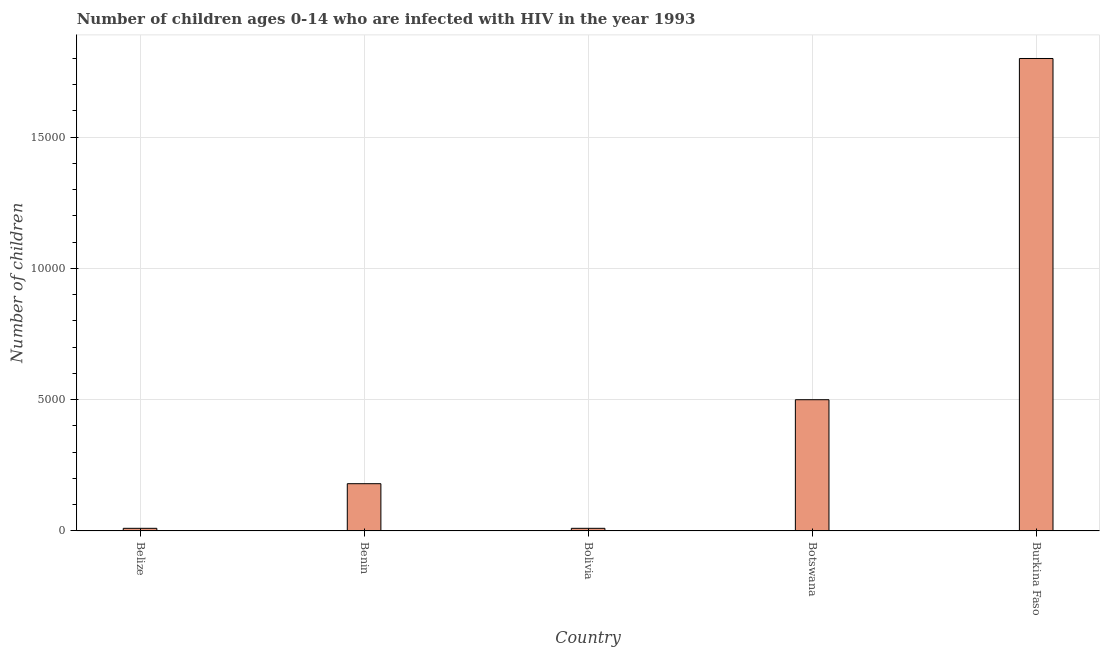Does the graph contain grids?
Your answer should be very brief. Yes. What is the title of the graph?
Provide a short and direct response. Number of children ages 0-14 who are infected with HIV in the year 1993. What is the label or title of the X-axis?
Your response must be concise. Country. What is the label or title of the Y-axis?
Provide a succinct answer. Number of children. Across all countries, what is the maximum number of children living with hiv?
Keep it short and to the point. 1.80e+04. Across all countries, what is the minimum number of children living with hiv?
Ensure brevity in your answer.  100. In which country was the number of children living with hiv maximum?
Make the answer very short. Burkina Faso. In which country was the number of children living with hiv minimum?
Offer a very short reply. Belize. What is the sum of the number of children living with hiv?
Your answer should be compact. 2.50e+04. What is the difference between the number of children living with hiv in Benin and Bolivia?
Make the answer very short. 1700. What is the median number of children living with hiv?
Ensure brevity in your answer.  1800. In how many countries, is the number of children living with hiv greater than 14000 ?
Provide a succinct answer. 1. What is the ratio of the number of children living with hiv in Benin to that in Botswana?
Your answer should be very brief. 0.36. What is the difference between the highest and the second highest number of children living with hiv?
Make the answer very short. 1.30e+04. What is the difference between the highest and the lowest number of children living with hiv?
Make the answer very short. 1.79e+04. In how many countries, is the number of children living with hiv greater than the average number of children living with hiv taken over all countries?
Your answer should be very brief. 1. Are the values on the major ticks of Y-axis written in scientific E-notation?
Offer a terse response. No. What is the Number of children in Benin?
Your response must be concise. 1800. What is the Number of children of Botswana?
Your answer should be compact. 5000. What is the Number of children of Burkina Faso?
Keep it short and to the point. 1.80e+04. What is the difference between the Number of children in Belize and Benin?
Your answer should be compact. -1700. What is the difference between the Number of children in Belize and Bolivia?
Provide a succinct answer. 0. What is the difference between the Number of children in Belize and Botswana?
Provide a short and direct response. -4900. What is the difference between the Number of children in Belize and Burkina Faso?
Provide a short and direct response. -1.79e+04. What is the difference between the Number of children in Benin and Bolivia?
Offer a terse response. 1700. What is the difference between the Number of children in Benin and Botswana?
Give a very brief answer. -3200. What is the difference between the Number of children in Benin and Burkina Faso?
Your answer should be very brief. -1.62e+04. What is the difference between the Number of children in Bolivia and Botswana?
Your answer should be compact. -4900. What is the difference between the Number of children in Bolivia and Burkina Faso?
Keep it short and to the point. -1.79e+04. What is the difference between the Number of children in Botswana and Burkina Faso?
Ensure brevity in your answer.  -1.30e+04. What is the ratio of the Number of children in Belize to that in Benin?
Your answer should be compact. 0.06. What is the ratio of the Number of children in Belize to that in Botswana?
Provide a short and direct response. 0.02. What is the ratio of the Number of children in Belize to that in Burkina Faso?
Ensure brevity in your answer.  0.01. What is the ratio of the Number of children in Benin to that in Botswana?
Provide a succinct answer. 0.36. What is the ratio of the Number of children in Benin to that in Burkina Faso?
Make the answer very short. 0.1. What is the ratio of the Number of children in Bolivia to that in Burkina Faso?
Ensure brevity in your answer.  0.01. What is the ratio of the Number of children in Botswana to that in Burkina Faso?
Provide a short and direct response. 0.28. 